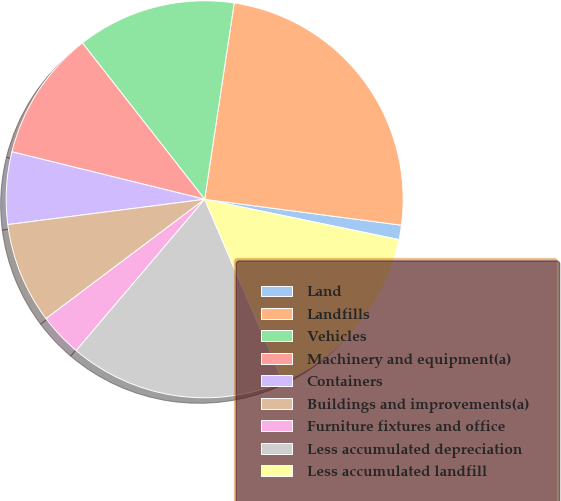Convert chart to OTSL. <chart><loc_0><loc_0><loc_500><loc_500><pie_chart><fcel>Land<fcel>Landfills<fcel>Vehicles<fcel>Machinery and equipment(a)<fcel>Containers<fcel>Buildings and improvements(a)<fcel>Furniture fixtures and office<fcel>Less accumulated depreciation<fcel>Less accumulated landfill<nl><fcel>1.17%<fcel>24.71%<fcel>12.94%<fcel>10.59%<fcel>5.88%<fcel>8.23%<fcel>3.53%<fcel>17.65%<fcel>15.3%<nl></chart> 